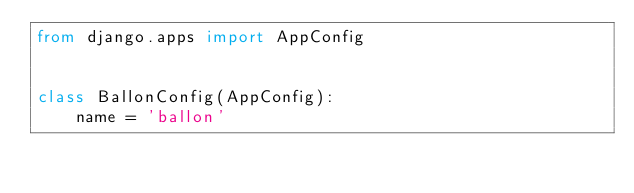Convert code to text. <code><loc_0><loc_0><loc_500><loc_500><_Python_>from django.apps import AppConfig


class BallonConfig(AppConfig):
    name = 'ballon'
</code> 